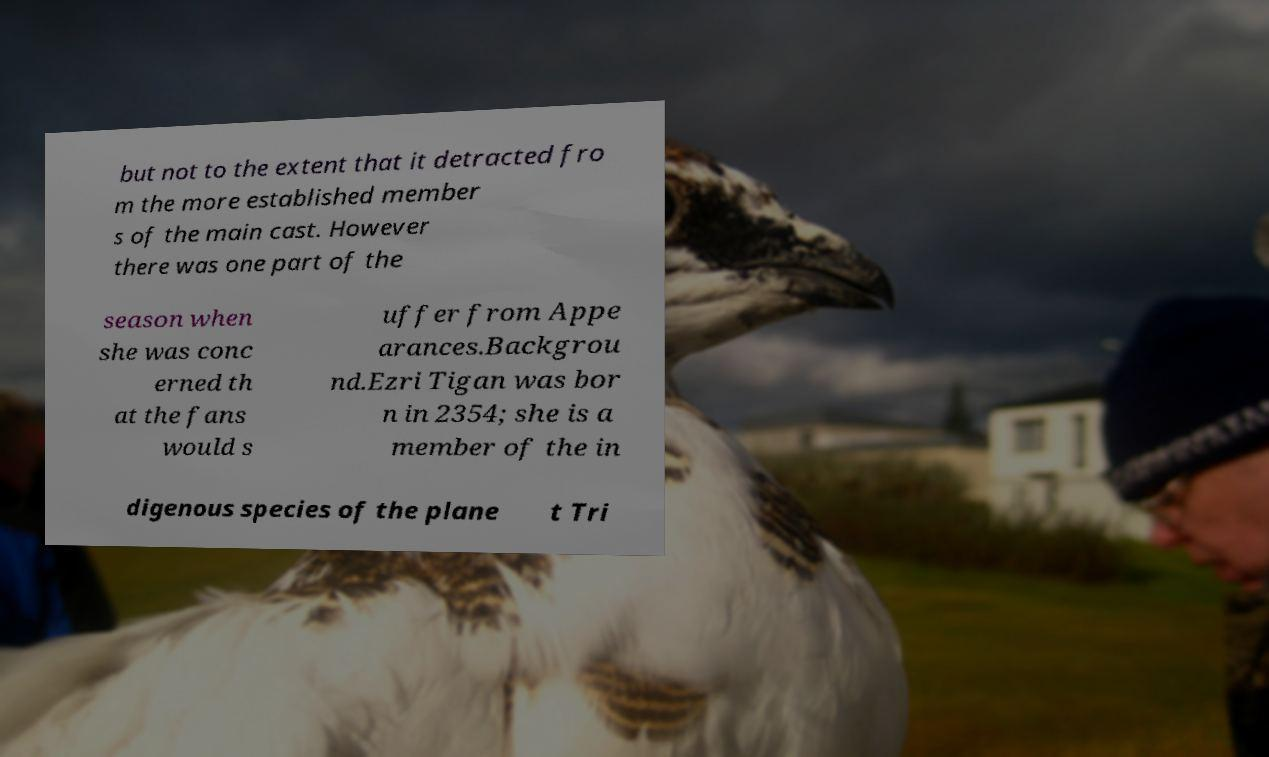For documentation purposes, I need the text within this image transcribed. Could you provide that? but not to the extent that it detracted fro m the more established member s of the main cast. However there was one part of the season when she was conc erned th at the fans would s uffer from Appe arances.Backgrou nd.Ezri Tigan was bor n in 2354; she is a member of the in digenous species of the plane t Tri 